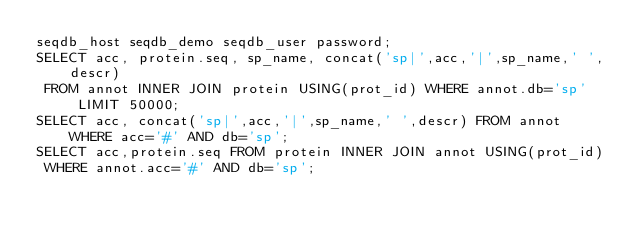<code> <loc_0><loc_0><loc_500><loc_500><_SQL_>seqdb_host seqdb_demo seqdb_user password;
SELECT acc, protein.seq, sp_name, concat('sp|',acc,'|',sp_name,' ',descr)
 FROM annot INNER JOIN protein USING(prot_id) WHERE annot.db='sp' LIMIT 50000;
SELECT acc, concat('sp|',acc,'|',sp_name,' ',descr) FROM annot WHERE acc='#' AND db='sp';
SELECT acc,protein.seq FROM protein INNER JOIN annot USING(prot_id)
 WHERE annot.acc='#' AND db='sp';
</code> 